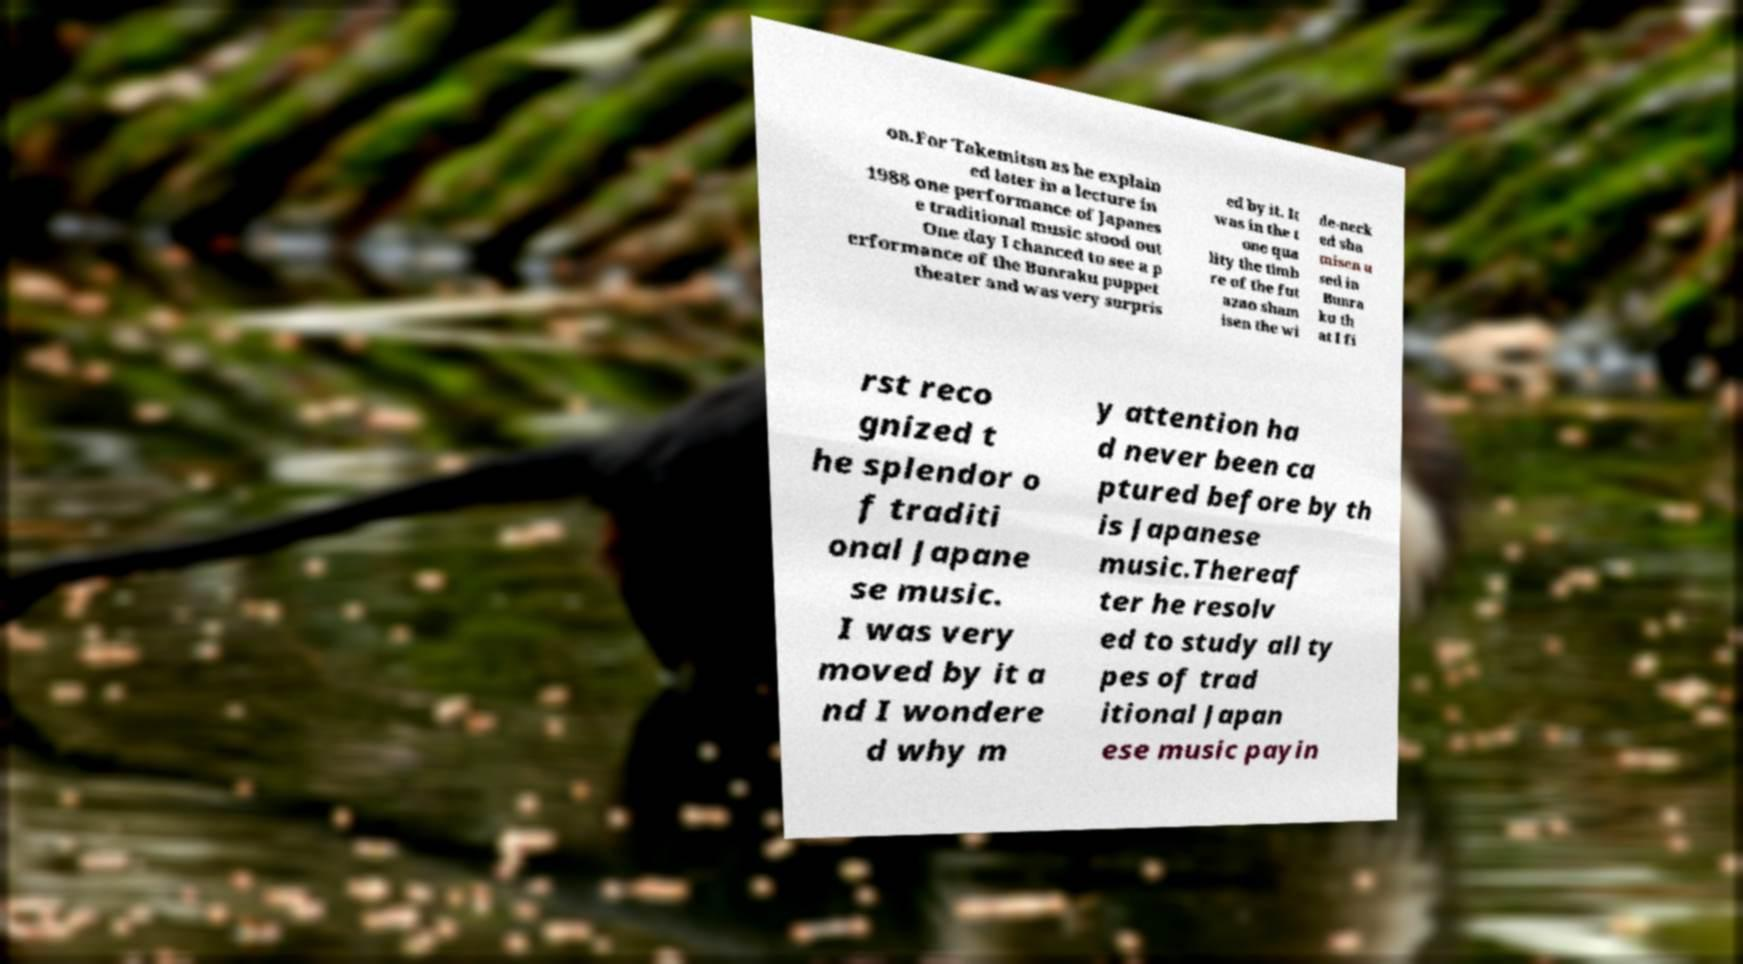There's text embedded in this image that I need extracted. Can you transcribe it verbatim? on.For Takemitsu as he explain ed later in a lecture in 1988 one performance of Japanes e traditional music stood out One day I chanced to see a p erformance of the Bunraku puppet theater and was very surpris ed by it. It was in the t one qua lity the timb re of the fut azao sham isen the wi de-neck ed sha misen u sed in Bunra ku th at I fi rst reco gnized t he splendor o f traditi onal Japane se music. I was very moved by it a nd I wondere d why m y attention ha d never been ca ptured before by th is Japanese music.Thereaf ter he resolv ed to study all ty pes of trad itional Japan ese music payin 